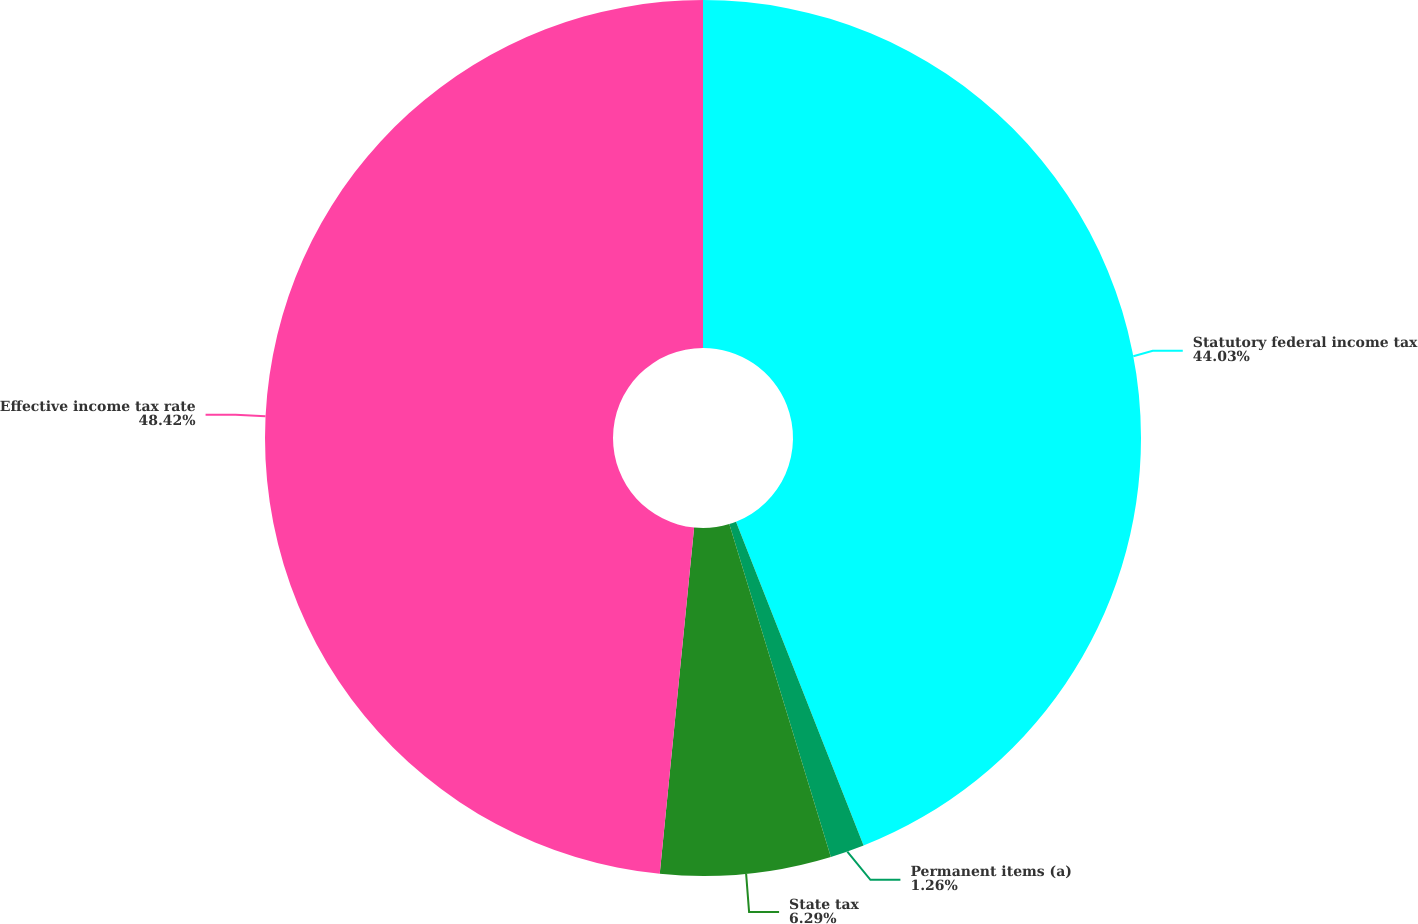<chart> <loc_0><loc_0><loc_500><loc_500><pie_chart><fcel>Statutory federal income tax<fcel>Permanent items (a)<fcel>State tax<fcel>Effective income tax rate<nl><fcel>44.03%<fcel>1.26%<fcel>6.29%<fcel>48.43%<nl></chart> 